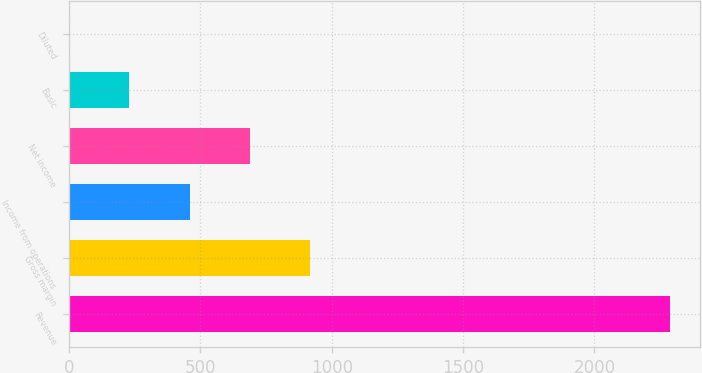Convert chart. <chart><loc_0><loc_0><loc_500><loc_500><bar_chart><fcel>Revenue<fcel>Gross margin<fcel>Income from operations<fcel>Net income<fcel>Basic<fcel>Diluted<nl><fcel>2289<fcel>915.93<fcel>458.23<fcel>687.08<fcel>229.38<fcel>0.53<nl></chart> 